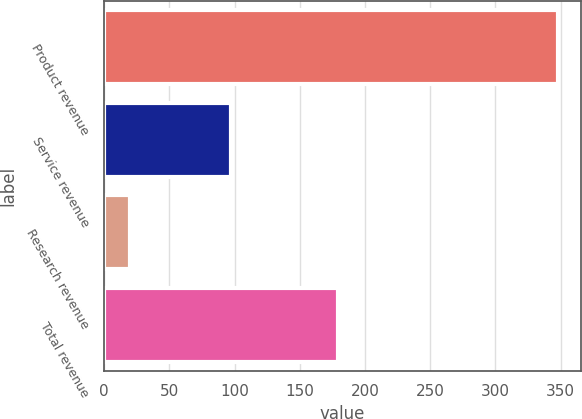Convert chart to OTSL. <chart><loc_0><loc_0><loc_500><loc_500><bar_chart><fcel>Product revenue<fcel>Service revenue<fcel>Research revenue<fcel>Total revenue<nl><fcel>348<fcel>97<fcel>20<fcel>179<nl></chart> 